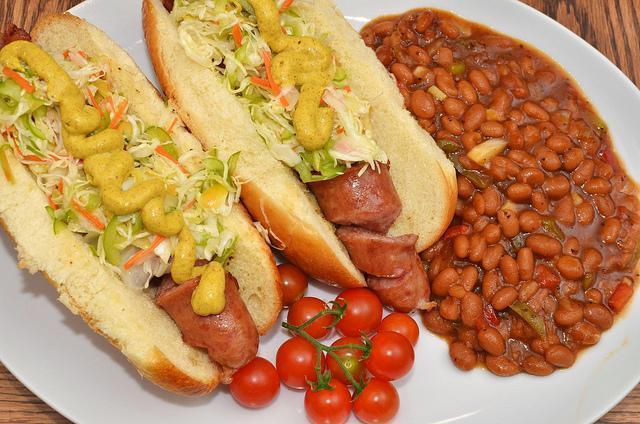How many hot dogs are there?
Give a very brief answer. 2. 